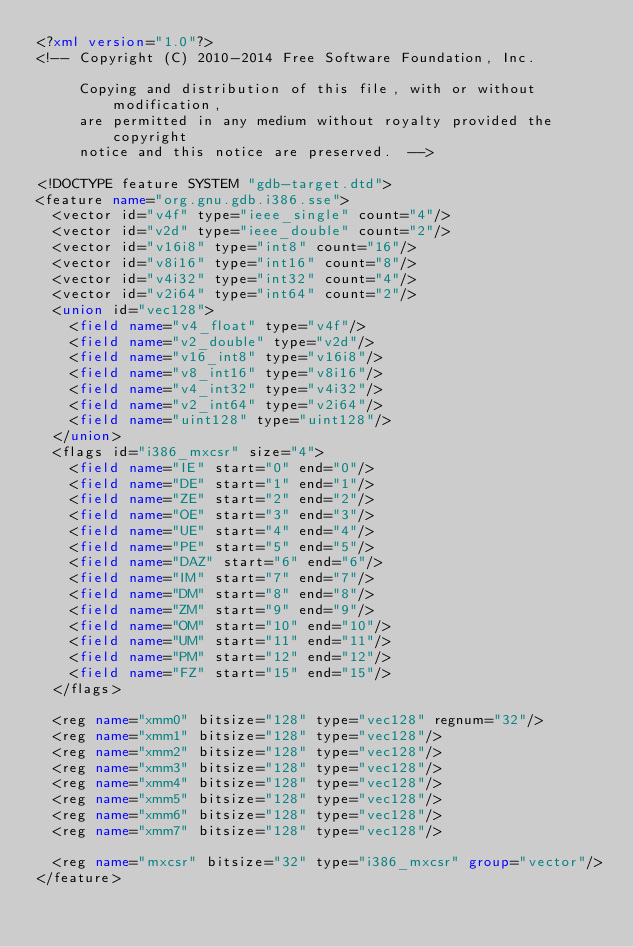<code> <loc_0><loc_0><loc_500><loc_500><_XML_><?xml version="1.0"?>
<!-- Copyright (C) 2010-2014 Free Software Foundation, Inc.

     Copying and distribution of this file, with or without modification,
     are permitted in any medium without royalty provided the copyright
     notice and this notice are preserved.  -->

<!DOCTYPE feature SYSTEM "gdb-target.dtd">
<feature name="org.gnu.gdb.i386.sse">
  <vector id="v4f" type="ieee_single" count="4"/>
  <vector id="v2d" type="ieee_double" count="2"/>
  <vector id="v16i8" type="int8" count="16"/>
  <vector id="v8i16" type="int16" count="8"/>
  <vector id="v4i32" type="int32" count="4"/>
  <vector id="v2i64" type="int64" count="2"/>
  <union id="vec128">
    <field name="v4_float" type="v4f"/>
    <field name="v2_double" type="v2d"/>
    <field name="v16_int8" type="v16i8"/>
    <field name="v8_int16" type="v8i16"/>
    <field name="v4_int32" type="v4i32"/>
    <field name="v2_int64" type="v2i64"/>
    <field name="uint128" type="uint128"/>
  </union>
  <flags id="i386_mxcsr" size="4">
    <field name="IE" start="0" end="0"/>
    <field name="DE" start="1" end="1"/>
    <field name="ZE" start="2" end="2"/>
    <field name="OE" start="3" end="3"/>
    <field name="UE" start="4" end="4"/>
    <field name="PE" start="5" end="5"/>
    <field name="DAZ" start="6" end="6"/>
    <field name="IM" start="7" end="7"/>
    <field name="DM" start="8" end="8"/>
    <field name="ZM" start="9" end="9"/>
    <field name="OM" start="10" end="10"/>
    <field name="UM" start="11" end="11"/>
    <field name="PM" start="12" end="12"/>
    <field name="FZ" start="15" end="15"/>
  </flags>

  <reg name="xmm0" bitsize="128" type="vec128" regnum="32"/>
  <reg name="xmm1" bitsize="128" type="vec128"/>
  <reg name="xmm2" bitsize="128" type="vec128"/>
  <reg name="xmm3" bitsize="128" type="vec128"/>
  <reg name="xmm4" bitsize="128" type="vec128"/>
  <reg name="xmm5" bitsize="128" type="vec128"/>
  <reg name="xmm6" bitsize="128" type="vec128"/>
  <reg name="xmm7" bitsize="128" type="vec128"/>

  <reg name="mxcsr" bitsize="32" type="i386_mxcsr" group="vector"/>
</feature>
</code> 